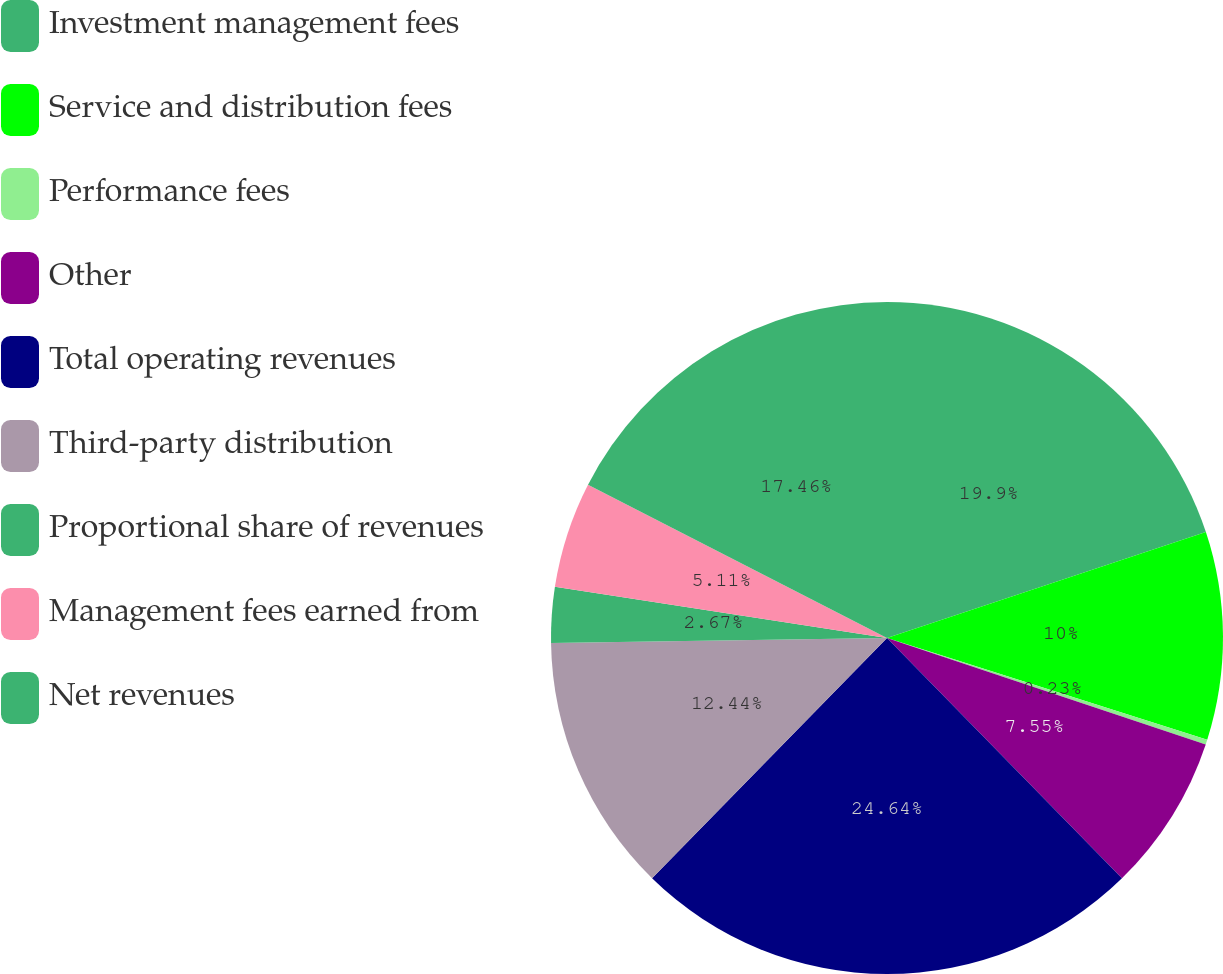Convert chart to OTSL. <chart><loc_0><loc_0><loc_500><loc_500><pie_chart><fcel>Investment management fees<fcel>Service and distribution fees<fcel>Performance fees<fcel>Other<fcel>Total operating revenues<fcel>Third-party distribution<fcel>Proportional share of revenues<fcel>Management fees earned from<fcel>Net revenues<nl><fcel>19.9%<fcel>10.0%<fcel>0.23%<fcel>7.55%<fcel>24.65%<fcel>12.44%<fcel>2.67%<fcel>5.11%<fcel>17.46%<nl></chart> 